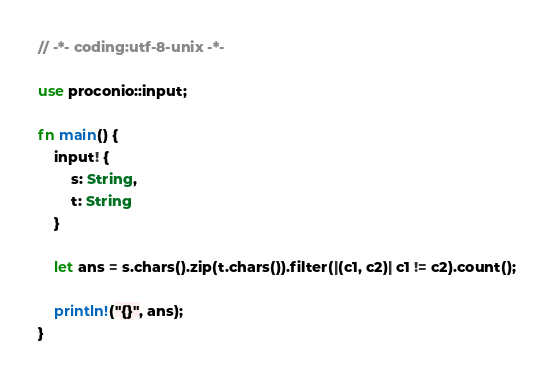Convert code to text. <code><loc_0><loc_0><loc_500><loc_500><_Rust_>// -*- coding:utf-8-unix -*-

use proconio::input;

fn main() {
    input! {
        s: String,
        t: String
    }

    let ans = s.chars().zip(t.chars()).filter(|(c1, c2)| c1 != c2).count();

    println!("{}", ans);
}
</code> 